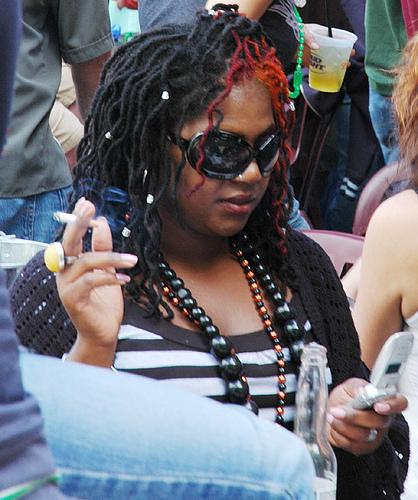What is the woman holding in her left hand?
Be succinct. Cell phone. What is covering the woman's eyes?
Be succinct. Sunglasses. What object in this photo is a cause of lung cancer?
Be succinct. Cigarette. 